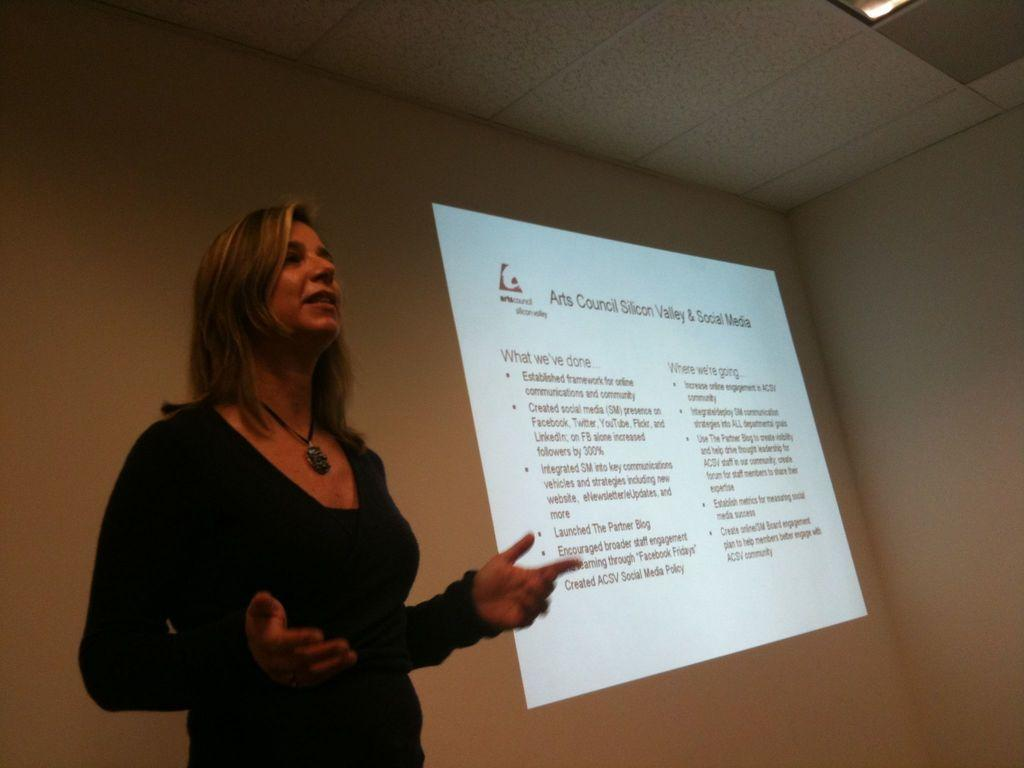What is the main subject of the image? There is a woman standing in the image. What can be seen behind the woman? There is a wall behind the woman. What is displayed on the wall? Text is displayed on the wall through a projector. What part of the room is visible at the top of the image? The ceiling is visible at the top of the image. How many kittens are sitting on the woman's shoulders in the image? There are no kittens present in the image. What type of lead is used to connect the projector to the wall in the image? The image does not provide information about the type of lead used to connect the projector to the wall. 